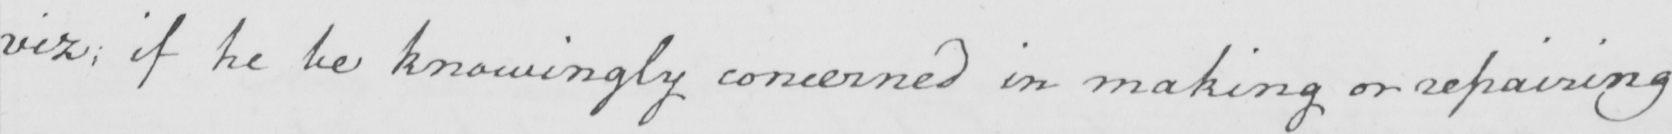What text is written in this handwritten line? viz :  if he be knowingly concerned in making or repairing 